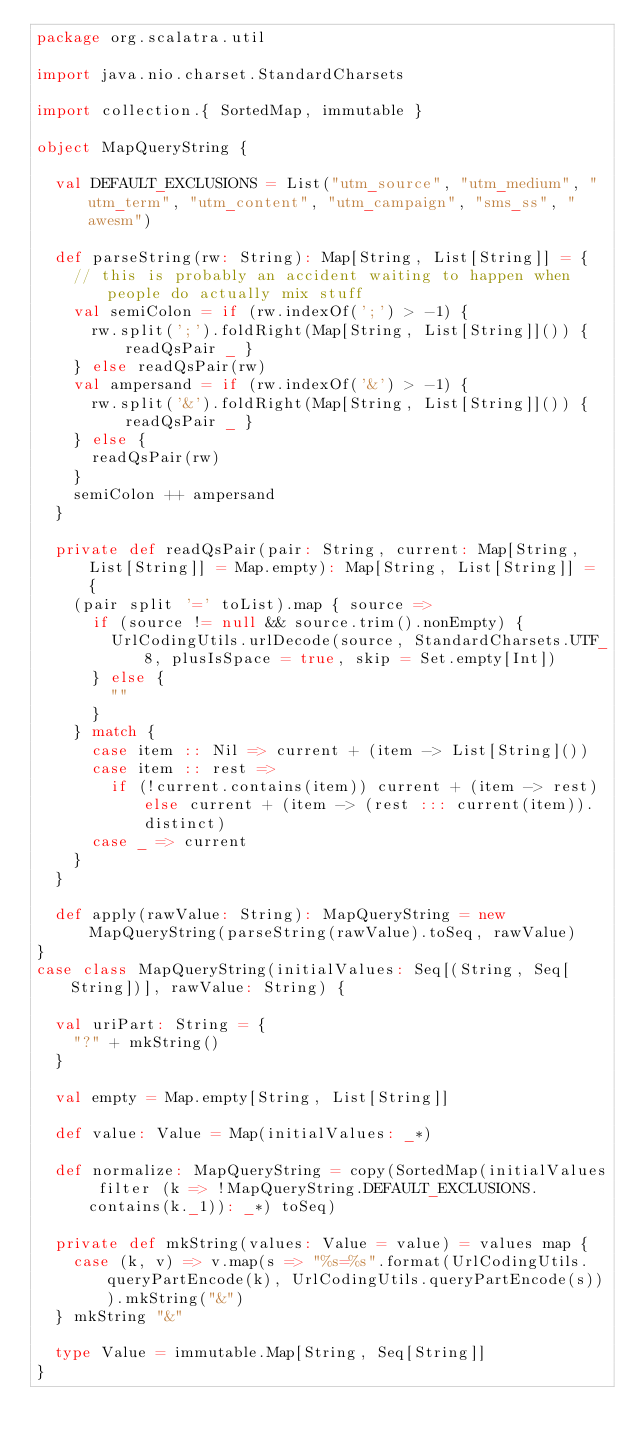<code> <loc_0><loc_0><loc_500><loc_500><_Scala_>package org.scalatra.util

import java.nio.charset.StandardCharsets

import collection.{ SortedMap, immutable }

object MapQueryString {

  val DEFAULT_EXCLUSIONS = List("utm_source", "utm_medium", "utm_term", "utm_content", "utm_campaign", "sms_ss", "awesm")

  def parseString(rw: String): Map[String, List[String]] = {
    // this is probably an accident waiting to happen when people do actually mix stuff
    val semiColon = if (rw.indexOf(';') > -1) {
      rw.split(';').foldRight(Map[String, List[String]]()) { readQsPair _ }
    } else readQsPair(rw)
    val ampersand = if (rw.indexOf('&') > -1) {
      rw.split('&').foldRight(Map[String, List[String]]()) { readQsPair _ }
    } else {
      readQsPair(rw)
    }
    semiColon ++ ampersand
  }

  private def readQsPair(pair: String, current: Map[String, List[String]] = Map.empty): Map[String, List[String]] = {
    (pair split '=' toList).map { source =>
      if (source != null && source.trim().nonEmpty) {
        UrlCodingUtils.urlDecode(source, StandardCharsets.UTF_8, plusIsSpace = true, skip = Set.empty[Int])
      } else {
        ""
      }
    } match {
      case item :: Nil => current + (item -> List[String]())
      case item :: rest =>
        if (!current.contains(item)) current + (item -> rest) else current + (item -> (rest ::: current(item)).distinct)
      case _ => current
    }
  }

  def apply(rawValue: String): MapQueryString = new MapQueryString(parseString(rawValue).toSeq, rawValue)
}
case class MapQueryString(initialValues: Seq[(String, Seq[String])], rawValue: String) {

  val uriPart: String = {
    "?" + mkString()
  }

  val empty = Map.empty[String, List[String]]

  def value: Value = Map(initialValues: _*)

  def normalize: MapQueryString = copy(SortedMap(initialValues filter (k => !MapQueryString.DEFAULT_EXCLUSIONS.contains(k._1)): _*) toSeq)

  private def mkString(values: Value = value) = values map {
    case (k, v) => v.map(s => "%s=%s".format(UrlCodingUtils.queryPartEncode(k), UrlCodingUtils.queryPartEncode(s))).mkString("&")
  } mkString "&"

  type Value = immutable.Map[String, Seq[String]]
}
</code> 